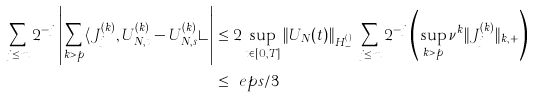Convert formula to latex. <formula><loc_0><loc_0><loc_500><loc_500>\sum _ { j \leq m } 2 ^ { - j } \left | \sum _ { k > p } \langle J _ { j } ^ { ( k ) } , U _ { N , t } ^ { ( k ) } - U _ { N , s } ^ { ( k ) } \rangle \right | & \leq 2 \sup _ { t \in [ 0 , T ] } \| U _ { N } ( t ) \| _ { H ^ { ( \nu ) } _ { - } } \sum _ { j \leq m } 2 ^ { - j } \left ( \sup _ { k > p } \nu ^ { k } \| J _ { j } ^ { ( k ) } \| _ { k , + } \right ) \\ & \leq \ e p s / 3</formula> 